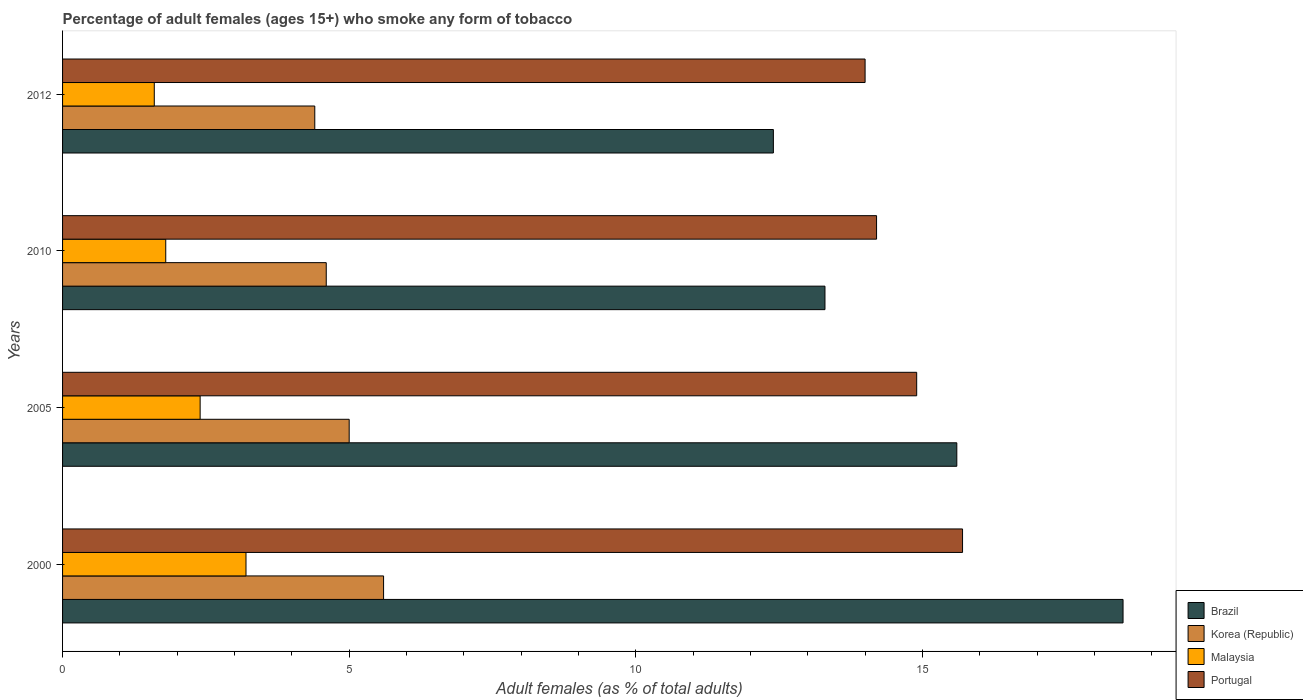How many different coloured bars are there?
Provide a short and direct response. 4. How many bars are there on the 2nd tick from the bottom?
Your response must be concise. 4. Across all years, what is the maximum percentage of adult females who smoke in Malaysia?
Provide a succinct answer. 3.2. Across all years, what is the minimum percentage of adult females who smoke in Malaysia?
Offer a terse response. 1.6. In which year was the percentage of adult females who smoke in Malaysia minimum?
Provide a short and direct response. 2012. What is the total percentage of adult females who smoke in Malaysia in the graph?
Offer a terse response. 9. What is the difference between the percentage of adult females who smoke in Korea (Republic) in 2005 and that in 2012?
Give a very brief answer. 0.6. In the year 2005, what is the difference between the percentage of adult females who smoke in Portugal and percentage of adult females who smoke in Brazil?
Make the answer very short. -0.7. In how many years, is the percentage of adult females who smoke in Korea (Republic) greater than 10 %?
Ensure brevity in your answer.  0. What is the ratio of the percentage of adult females who smoke in Brazil in 2005 to that in 2010?
Provide a short and direct response. 1.17. Is the difference between the percentage of adult females who smoke in Portugal in 2005 and 2010 greater than the difference between the percentage of adult females who smoke in Brazil in 2005 and 2010?
Your response must be concise. No. What is the difference between the highest and the second highest percentage of adult females who smoke in Malaysia?
Ensure brevity in your answer.  0.8. What is the difference between the highest and the lowest percentage of adult females who smoke in Brazil?
Offer a terse response. 6.1. What does the 1st bar from the top in 2010 represents?
Your response must be concise. Portugal. What does the 3rd bar from the bottom in 2012 represents?
Your answer should be compact. Malaysia. Is it the case that in every year, the sum of the percentage of adult females who smoke in Korea (Republic) and percentage of adult females who smoke in Brazil is greater than the percentage of adult females who smoke in Portugal?
Give a very brief answer. Yes. How many bars are there?
Your response must be concise. 16. How many years are there in the graph?
Offer a terse response. 4. Are the values on the major ticks of X-axis written in scientific E-notation?
Offer a very short reply. No. Does the graph contain any zero values?
Your answer should be compact. No. Where does the legend appear in the graph?
Offer a terse response. Bottom right. What is the title of the graph?
Your response must be concise. Percentage of adult females (ages 15+) who smoke any form of tobacco. Does "Haiti" appear as one of the legend labels in the graph?
Your response must be concise. No. What is the label or title of the X-axis?
Your response must be concise. Adult females (as % of total adults). What is the Adult females (as % of total adults) of Brazil in 2000?
Offer a very short reply. 18.5. What is the Adult females (as % of total adults) in Korea (Republic) in 2000?
Offer a very short reply. 5.6. What is the Adult females (as % of total adults) in Malaysia in 2000?
Offer a terse response. 3.2. What is the Adult females (as % of total adults) in Portugal in 2000?
Offer a terse response. 15.7. What is the Adult females (as % of total adults) in Brazil in 2005?
Ensure brevity in your answer.  15.6. What is the Adult females (as % of total adults) of Korea (Republic) in 2005?
Ensure brevity in your answer.  5. What is the Adult females (as % of total adults) of Brazil in 2010?
Ensure brevity in your answer.  13.3. What is the Adult females (as % of total adults) in Portugal in 2010?
Offer a terse response. 14.2. What is the Adult females (as % of total adults) of Brazil in 2012?
Provide a succinct answer. 12.4. What is the Adult females (as % of total adults) in Korea (Republic) in 2012?
Give a very brief answer. 4.4. Across all years, what is the maximum Adult females (as % of total adults) in Korea (Republic)?
Provide a short and direct response. 5.6. Across all years, what is the maximum Adult females (as % of total adults) in Malaysia?
Offer a terse response. 3.2. Across all years, what is the minimum Adult females (as % of total adults) of Brazil?
Provide a succinct answer. 12.4. Across all years, what is the minimum Adult females (as % of total adults) of Korea (Republic)?
Your answer should be compact. 4.4. Across all years, what is the minimum Adult females (as % of total adults) in Malaysia?
Ensure brevity in your answer.  1.6. Across all years, what is the minimum Adult females (as % of total adults) in Portugal?
Your answer should be compact. 14. What is the total Adult females (as % of total adults) of Brazil in the graph?
Give a very brief answer. 59.8. What is the total Adult females (as % of total adults) in Korea (Republic) in the graph?
Provide a succinct answer. 19.6. What is the total Adult females (as % of total adults) in Malaysia in the graph?
Keep it short and to the point. 9. What is the total Adult females (as % of total adults) of Portugal in the graph?
Provide a succinct answer. 58.8. What is the difference between the Adult females (as % of total adults) in Brazil in 2000 and that in 2005?
Your answer should be compact. 2.9. What is the difference between the Adult females (as % of total adults) of Portugal in 2000 and that in 2005?
Give a very brief answer. 0.8. What is the difference between the Adult females (as % of total adults) in Korea (Republic) in 2000 and that in 2010?
Offer a terse response. 1. What is the difference between the Adult females (as % of total adults) in Brazil in 2000 and that in 2012?
Give a very brief answer. 6.1. What is the difference between the Adult females (as % of total adults) in Malaysia in 2000 and that in 2012?
Give a very brief answer. 1.6. What is the difference between the Adult females (as % of total adults) in Portugal in 2000 and that in 2012?
Offer a very short reply. 1.7. What is the difference between the Adult females (as % of total adults) in Portugal in 2005 and that in 2010?
Make the answer very short. 0.7. What is the difference between the Adult females (as % of total adults) in Brazil in 2005 and that in 2012?
Keep it short and to the point. 3.2. What is the difference between the Adult females (as % of total adults) in Korea (Republic) in 2005 and that in 2012?
Keep it short and to the point. 0.6. What is the difference between the Adult females (as % of total adults) in Portugal in 2005 and that in 2012?
Keep it short and to the point. 0.9. What is the difference between the Adult females (as % of total adults) of Brazil in 2010 and that in 2012?
Your response must be concise. 0.9. What is the difference between the Adult females (as % of total adults) in Korea (Republic) in 2010 and that in 2012?
Your answer should be compact. 0.2. What is the difference between the Adult females (as % of total adults) of Malaysia in 2010 and that in 2012?
Keep it short and to the point. 0.2. What is the difference between the Adult females (as % of total adults) of Brazil in 2000 and the Adult females (as % of total adults) of Portugal in 2005?
Your answer should be compact. 3.6. What is the difference between the Adult females (as % of total adults) of Korea (Republic) in 2000 and the Adult females (as % of total adults) of Portugal in 2005?
Make the answer very short. -9.3. What is the difference between the Adult females (as % of total adults) of Brazil in 2000 and the Adult females (as % of total adults) of Malaysia in 2010?
Provide a short and direct response. 16.7. What is the difference between the Adult females (as % of total adults) in Brazil in 2000 and the Adult females (as % of total adults) in Portugal in 2010?
Keep it short and to the point. 4.3. What is the difference between the Adult females (as % of total adults) of Korea (Republic) in 2000 and the Adult females (as % of total adults) of Malaysia in 2010?
Give a very brief answer. 3.8. What is the difference between the Adult females (as % of total adults) in Korea (Republic) in 2000 and the Adult females (as % of total adults) in Portugal in 2010?
Provide a short and direct response. -8.6. What is the difference between the Adult females (as % of total adults) in Brazil in 2000 and the Adult females (as % of total adults) in Korea (Republic) in 2012?
Make the answer very short. 14.1. What is the difference between the Adult females (as % of total adults) of Korea (Republic) in 2000 and the Adult females (as % of total adults) of Malaysia in 2012?
Give a very brief answer. 4. What is the difference between the Adult females (as % of total adults) of Korea (Republic) in 2000 and the Adult females (as % of total adults) of Portugal in 2012?
Make the answer very short. -8.4. What is the difference between the Adult females (as % of total adults) in Malaysia in 2000 and the Adult females (as % of total adults) in Portugal in 2012?
Your answer should be compact. -10.8. What is the difference between the Adult females (as % of total adults) in Brazil in 2005 and the Adult females (as % of total adults) in Malaysia in 2010?
Your response must be concise. 13.8. What is the difference between the Adult females (as % of total adults) in Brazil in 2005 and the Adult females (as % of total adults) in Portugal in 2010?
Offer a very short reply. 1.4. What is the difference between the Adult females (as % of total adults) of Malaysia in 2005 and the Adult females (as % of total adults) of Portugal in 2010?
Provide a succinct answer. -11.8. What is the difference between the Adult females (as % of total adults) of Brazil in 2005 and the Adult females (as % of total adults) of Korea (Republic) in 2012?
Your answer should be compact. 11.2. What is the difference between the Adult females (as % of total adults) in Brazil in 2005 and the Adult females (as % of total adults) in Malaysia in 2012?
Offer a terse response. 14. What is the difference between the Adult females (as % of total adults) of Brazil in 2005 and the Adult females (as % of total adults) of Portugal in 2012?
Provide a succinct answer. 1.6. What is the difference between the Adult females (as % of total adults) in Korea (Republic) in 2005 and the Adult females (as % of total adults) in Portugal in 2012?
Your answer should be very brief. -9. What is the difference between the Adult females (as % of total adults) in Malaysia in 2005 and the Adult females (as % of total adults) in Portugal in 2012?
Keep it short and to the point. -11.6. What is the difference between the Adult females (as % of total adults) of Brazil in 2010 and the Adult females (as % of total adults) of Korea (Republic) in 2012?
Your answer should be very brief. 8.9. What is the difference between the Adult females (as % of total adults) in Brazil in 2010 and the Adult females (as % of total adults) in Malaysia in 2012?
Provide a succinct answer. 11.7. What is the difference between the Adult females (as % of total adults) of Korea (Republic) in 2010 and the Adult females (as % of total adults) of Portugal in 2012?
Offer a very short reply. -9.4. What is the average Adult females (as % of total adults) of Brazil per year?
Give a very brief answer. 14.95. What is the average Adult females (as % of total adults) of Korea (Republic) per year?
Give a very brief answer. 4.9. What is the average Adult females (as % of total adults) of Malaysia per year?
Your answer should be compact. 2.25. What is the average Adult females (as % of total adults) of Portugal per year?
Your response must be concise. 14.7. In the year 2000, what is the difference between the Adult females (as % of total adults) of Brazil and Adult females (as % of total adults) of Korea (Republic)?
Your answer should be compact. 12.9. In the year 2000, what is the difference between the Adult females (as % of total adults) in Brazil and Adult females (as % of total adults) in Malaysia?
Your answer should be very brief. 15.3. In the year 2000, what is the difference between the Adult females (as % of total adults) of Brazil and Adult females (as % of total adults) of Portugal?
Offer a very short reply. 2.8. In the year 2000, what is the difference between the Adult females (as % of total adults) of Korea (Republic) and Adult females (as % of total adults) of Malaysia?
Your answer should be very brief. 2.4. In the year 2000, what is the difference between the Adult females (as % of total adults) in Korea (Republic) and Adult females (as % of total adults) in Portugal?
Your answer should be very brief. -10.1. In the year 2000, what is the difference between the Adult females (as % of total adults) in Malaysia and Adult females (as % of total adults) in Portugal?
Provide a short and direct response. -12.5. In the year 2005, what is the difference between the Adult females (as % of total adults) of Brazil and Adult females (as % of total adults) of Malaysia?
Make the answer very short. 13.2. In the year 2010, what is the difference between the Adult females (as % of total adults) in Brazil and Adult females (as % of total adults) in Korea (Republic)?
Make the answer very short. 8.7. In the year 2010, what is the difference between the Adult females (as % of total adults) of Brazil and Adult females (as % of total adults) of Malaysia?
Your response must be concise. 11.5. In the year 2012, what is the difference between the Adult females (as % of total adults) in Brazil and Adult females (as % of total adults) in Korea (Republic)?
Give a very brief answer. 8. In the year 2012, what is the difference between the Adult females (as % of total adults) of Brazil and Adult females (as % of total adults) of Portugal?
Provide a short and direct response. -1.6. In the year 2012, what is the difference between the Adult females (as % of total adults) in Korea (Republic) and Adult females (as % of total adults) in Malaysia?
Keep it short and to the point. 2.8. In the year 2012, what is the difference between the Adult females (as % of total adults) in Korea (Republic) and Adult females (as % of total adults) in Portugal?
Make the answer very short. -9.6. In the year 2012, what is the difference between the Adult females (as % of total adults) of Malaysia and Adult females (as % of total adults) of Portugal?
Make the answer very short. -12.4. What is the ratio of the Adult females (as % of total adults) in Brazil in 2000 to that in 2005?
Your answer should be very brief. 1.19. What is the ratio of the Adult females (as % of total adults) of Korea (Republic) in 2000 to that in 2005?
Keep it short and to the point. 1.12. What is the ratio of the Adult females (as % of total adults) in Portugal in 2000 to that in 2005?
Your response must be concise. 1.05. What is the ratio of the Adult females (as % of total adults) of Brazil in 2000 to that in 2010?
Offer a terse response. 1.39. What is the ratio of the Adult females (as % of total adults) in Korea (Republic) in 2000 to that in 2010?
Your response must be concise. 1.22. What is the ratio of the Adult females (as % of total adults) of Malaysia in 2000 to that in 2010?
Provide a short and direct response. 1.78. What is the ratio of the Adult females (as % of total adults) of Portugal in 2000 to that in 2010?
Offer a terse response. 1.11. What is the ratio of the Adult females (as % of total adults) in Brazil in 2000 to that in 2012?
Make the answer very short. 1.49. What is the ratio of the Adult females (as % of total adults) in Korea (Republic) in 2000 to that in 2012?
Make the answer very short. 1.27. What is the ratio of the Adult females (as % of total adults) of Malaysia in 2000 to that in 2012?
Give a very brief answer. 2. What is the ratio of the Adult females (as % of total adults) of Portugal in 2000 to that in 2012?
Provide a succinct answer. 1.12. What is the ratio of the Adult females (as % of total adults) of Brazil in 2005 to that in 2010?
Ensure brevity in your answer.  1.17. What is the ratio of the Adult females (as % of total adults) in Korea (Republic) in 2005 to that in 2010?
Keep it short and to the point. 1.09. What is the ratio of the Adult females (as % of total adults) of Malaysia in 2005 to that in 2010?
Give a very brief answer. 1.33. What is the ratio of the Adult females (as % of total adults) of Portugal in 2005 to that in 2010?
Offer a very short reply. 1.05. What is the ratio of the Adult females (as % of total adults) of Brazil in 2005 to that in 2012?
Give a very brief answer. 1.26. What is the ratio of the Adult females (as % of total adults) of Korea (Republic) in 2005 to that in 2012?
Provide a short and direct response. 1.14. What is the ratio of the Adult females (as % of total adults) in Portugal in 2005 to that in 2012?
Keep it short and to the point. 1.06. What is the ratio of the Adult females (as % of total adults) of Brazil in 2010 to that in 2012?
Your response must be concise. 1.07. What is the ratio of the Adult females (as % of total adults) of Korea (Republic) in 2010 to that in 2012?
Provide a short and direct response. 1.05. What is the ratio of the Adult females (as % of total adults) of Malaysia in 2010 to that in 2012?
Provide a short and direct response. 1.12. What is the ratio of the Adult females (as % of total adults) in Portugal in 2010 to that in 2012?
Keep it short and to the point. 1.01. What is the difference between the highest and the second highest Adult females (as % of total adults) in Korea (Republic)?
Your response must be concise. 0.6. What is the difference between the highest and the lowest Adult females (as % of total adults) of Brazil?
Ensure brevity in your answer.  6.1. 